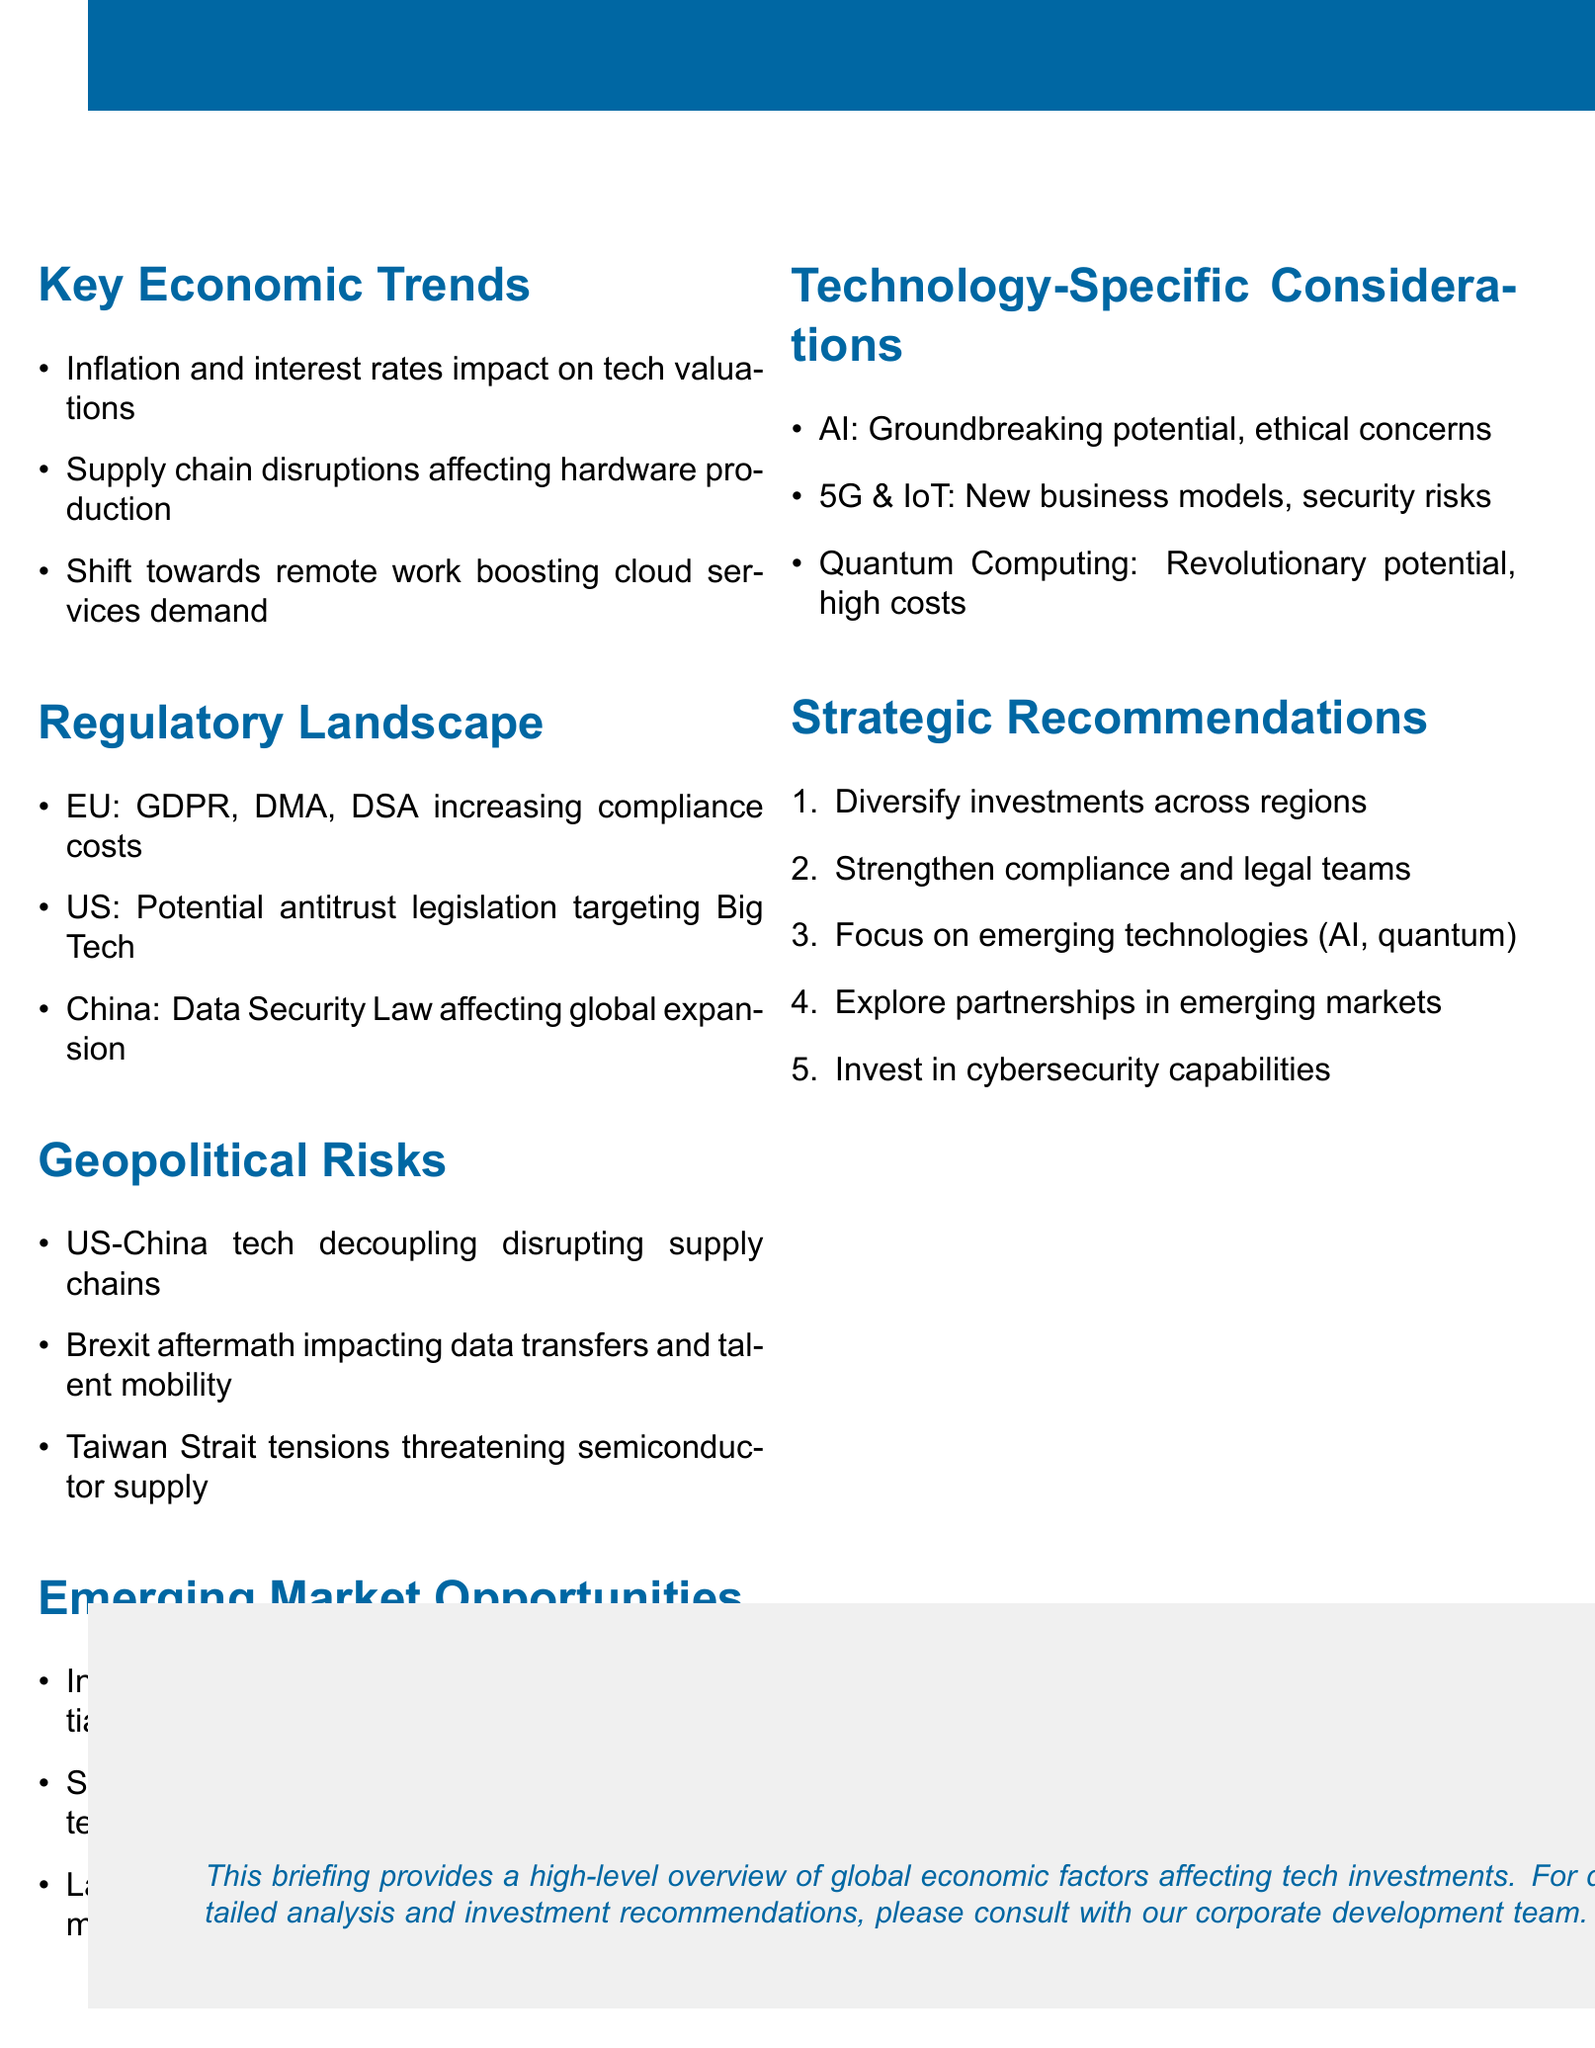What is the title of the briefing document? The title of the briefing document is clearly stated in the header of the document.
Answer: Global Economic Factors Impacting Tech Investments What are the regulatory changes in the European Union? The document lists key regulations impacting the EU region, which include several specific laws.
Answer: GDPR, Digital Markets Act, Digital Services Act What is the impact of inflation and interest rates on tech investments? The document describes how macroeconomic trends like inflation affect the technology sector.
Answer: Higher costs of capital affecting tech valuations and M&A activity Which emerging market is noted for its 'Digital India' initiative? The document identifies opportunities in various emerging markets while highlighting specific initiatives.
Answer: India What key risk is associated with the US-China tech decoupling? The geopolitical section discusses various risks to technology investments and defines specific impacts.
Answer: Disruption of global supply chains and market access restrictions What is one of the strategic recommendations provided in the document? The strategic recommendations section summarizes key actions for tech investments based on the analysis presented.
Answer: Diversify investments across regions to mitigate geopolitical risks 